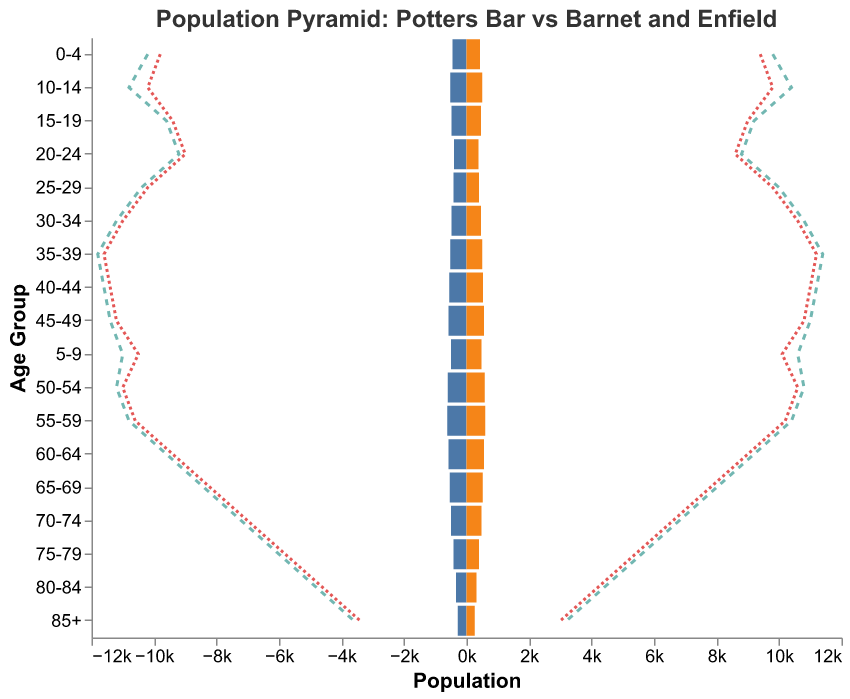What is the title of the plot? The title of the plot is usually located at the top center. In this figure, it should clearly state the purpose of the plot.
Answer: Population Pyramid: Potters Bar vs Barnet and Enfield What is the population of females in the age group 60-64 in Potters Bar? To find the population of females in the age group 60-64 in Potters Bar, locate the 60-64 age group and check the value under the column for Potters Bar Females.
Answer: 560 In which age group does Potters Bar have the highest total population (males + females)? To find the age group with the highest total population, sum the values of Potters Bar Males and Potters Bar Females for each age group and determine which is largest.
Answer: 55-59 How do the male populations in the age group 25-29 compare between Potters Bar, Barnet, and Enfield? Locate the values for Barnet Males, Potters Bar Males, and Enfield Males in the 25-29 age group and compare them. Barnet Males is 10400, Potters Bar Males is 420, and Enfield Males is 10200.
Answer: Barnet has the largest, followed by Enfield, and then Potters Bar Calculate the average population of females across all age groups in Barnet Sum all values in the Barnet Females column and then divide by the number of age groups (which is the total number of rows). Sum = 9800 + 10600 + 10400 + 9200 + 8800 + 10000 + 10800 + 11400 + 11200 + 11000 + 10800 + 10400 + 9200 + 8000 + 6800 + 5600 + 4400 + 3200 = 153400, there are 18 age groups. Average = 153400 / 18.
Answer: 8522.22 Which town has the smallest population in the age group 85+ for both genders combined? Locate the values for both males and females in the age group 85+ for Potters Bar, Barnet, and Enfield. Sum the male and female populations in this age group for each town and compare. Potters Bar: (280 + 260) = 540, Barnet: (3600 + 3200) = 6800, Enfield: (3400 + 3000) = 6400.
Answer: Potters Bar 